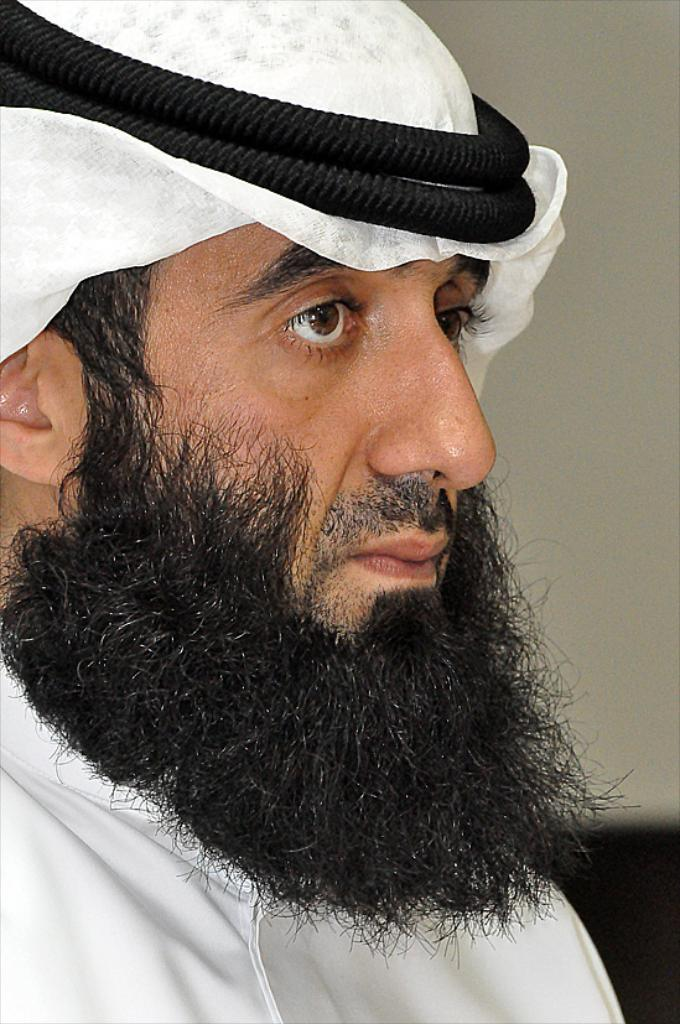Who or what is the main subject in the image? There is a person in the image. What is the person wearing? The person is wearing a white dress. What color is the background of the image? The background of the image is cream-colored. What store can be seen in the background of the image? There is no store visible in the background of the image; it is a cream-colored background. 